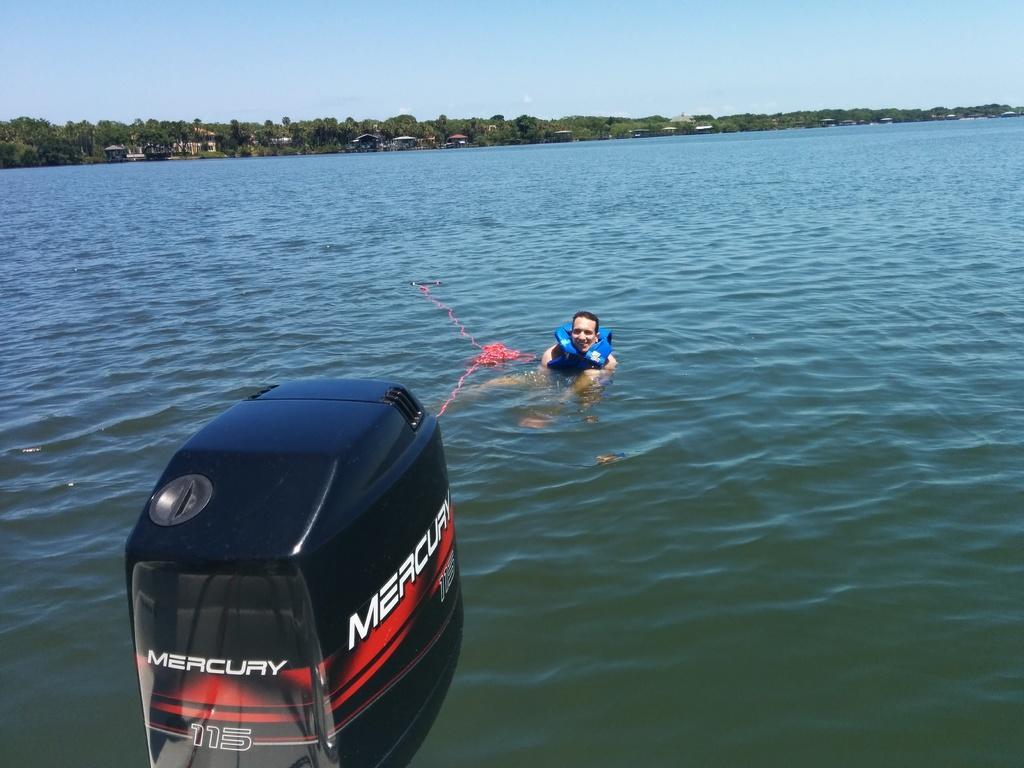Can you describe this image briefly? In this image we can see one man and wearing an object, we can see the water, there are trees, houses in the background, at the top we can see the sky, at the bottom we can see an object. 